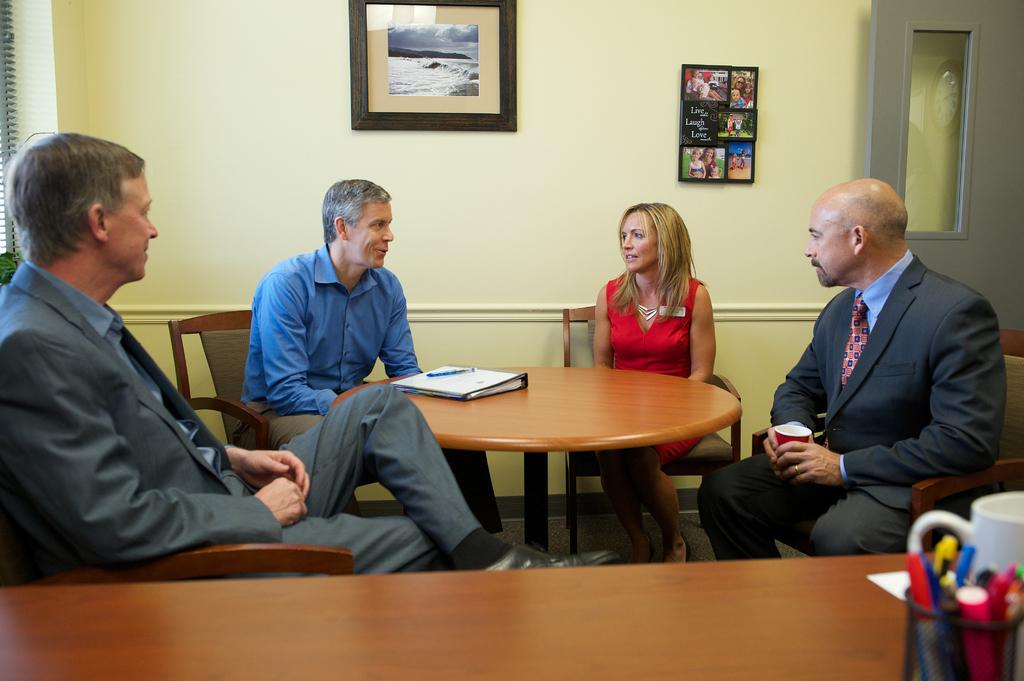How many people are in the group in the image? There is a group of four people in the image. What are the people in the group doing? They are engaged in a discussion. Can you describe the gender distribution of the group? Three of the people are men, and one is a woman. Where are the people in the group located? They are sitting around a table. What type of locket is the woman wearing in the image? There is no locket visible on the woman in the image. What type of drink is being shared among the group in the image? There is no drink present in the image; the group is engaged in a discussion. 